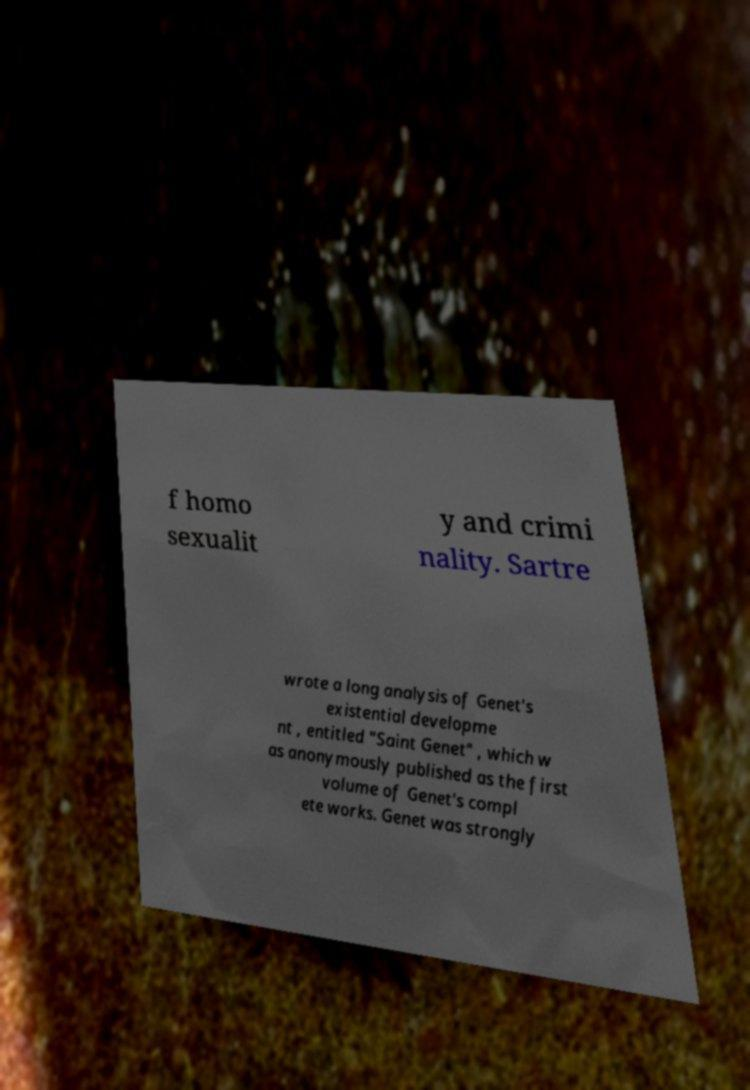Can you read and provide the text displayed in the image?This photo seems to have some interesting text. Can you extract and type it out for me? f homo sexualit y and crimi nality. Sartre wrote a long analysis of Genet's existential developme nt , entitled "Saint Genet" , which w as anonymously published as the first volume of Genet's compl ete works. Genet was strongly 